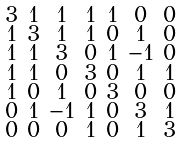<formula> <loc_0><loc_0><loc_500><loc_500>\begin{smallmatrix} 3 & 1 & 1 & 1 & 1 & 0 & 0 \\ 1 & 3 & 1 & 1 & 0 & 1 & 0 \\ 1 & 1 & 3 & 0 & 1 & - 1 & 0 \\ 1 & 1 & 0 & 3 & 0 & 1 & 1 \\ 1 & 0 & 1 & 0 & 3 & 0 & 0 \\ 0 & 1 & - 1 & 1 & 0 & 3 & 1 \\ 0 & 0 & 0 & 1 & 0 & 1 & 3 \end{smallmatrix}</formula> 